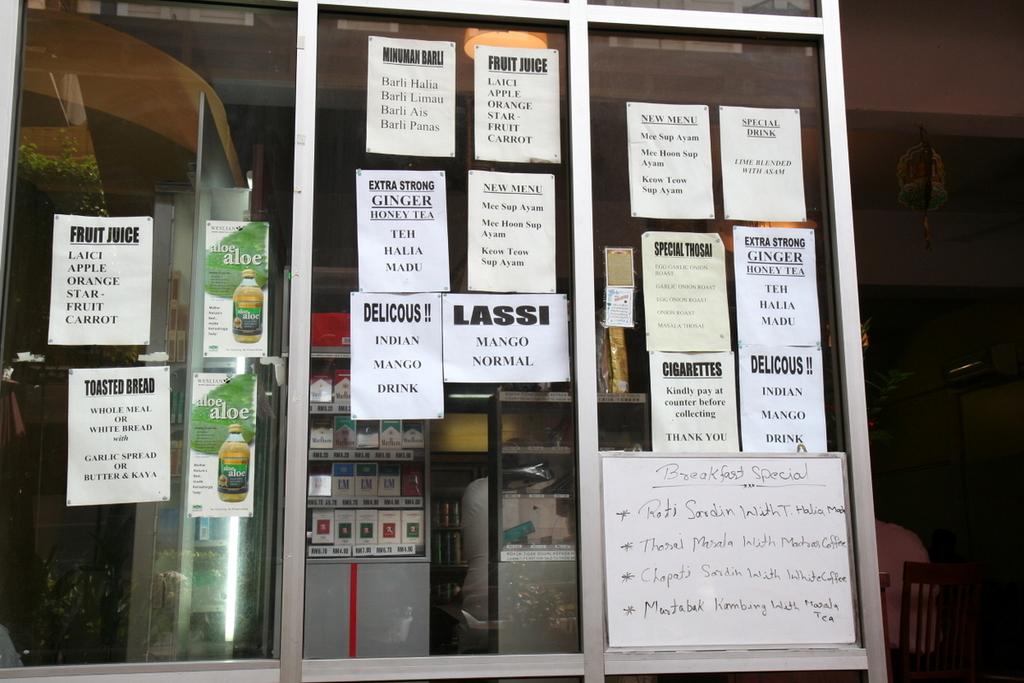What type of fliers are there on the windows?
Provide a succinct answer. Unanswerable. What is the title on the dry erase board?
Offer a very short reply. Breakfast special. 